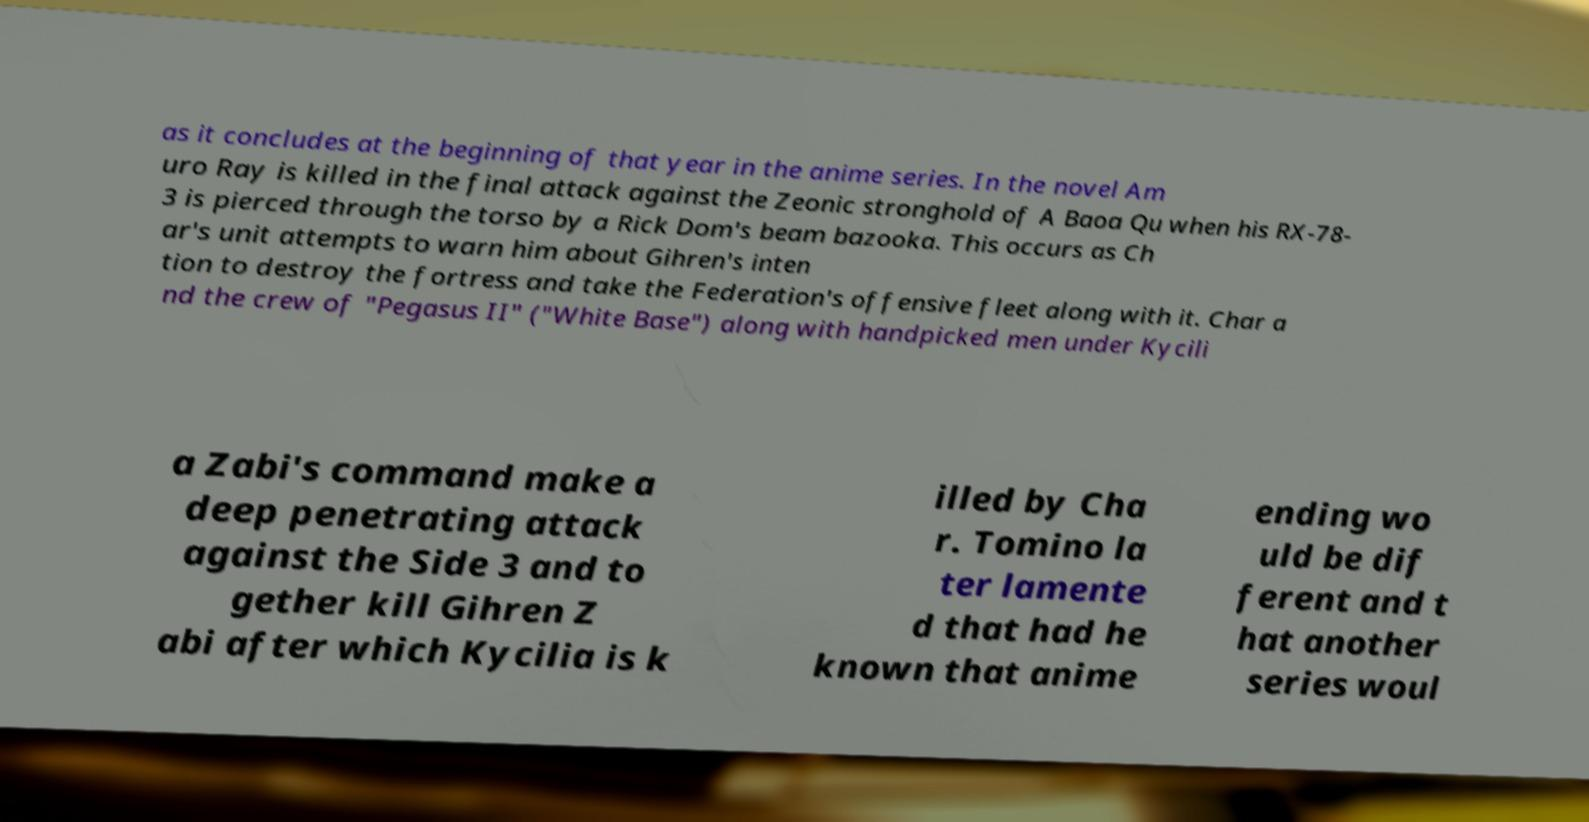Could you extract and type out the text from this image? as it concludes at the beginning of that year in the anime series. In the novel Am uro Ray is killed in the final attack against the Zeonic stronghold of A Baoa Qu when his RX-78- 3 is pierced through the torso by a Rick Dom's beam bazooka. This occurs as Ch ar's unit attempts to warn him about Gihren's inten tion to destroy the fortress and take the Federation's offensive fleet along with it. Char a nd the crew of "Pegasus II" ("White Base") along with handpicked men under Kycili a Zabi's command make a deep penetrating attack against the Side 3 and to gether kill Gihren Z abi after which Kycilia is k illed by Cha r. Tomino la ter lamente d that had he known that anime ending wo uld be dif ferent and t hat another series woul 